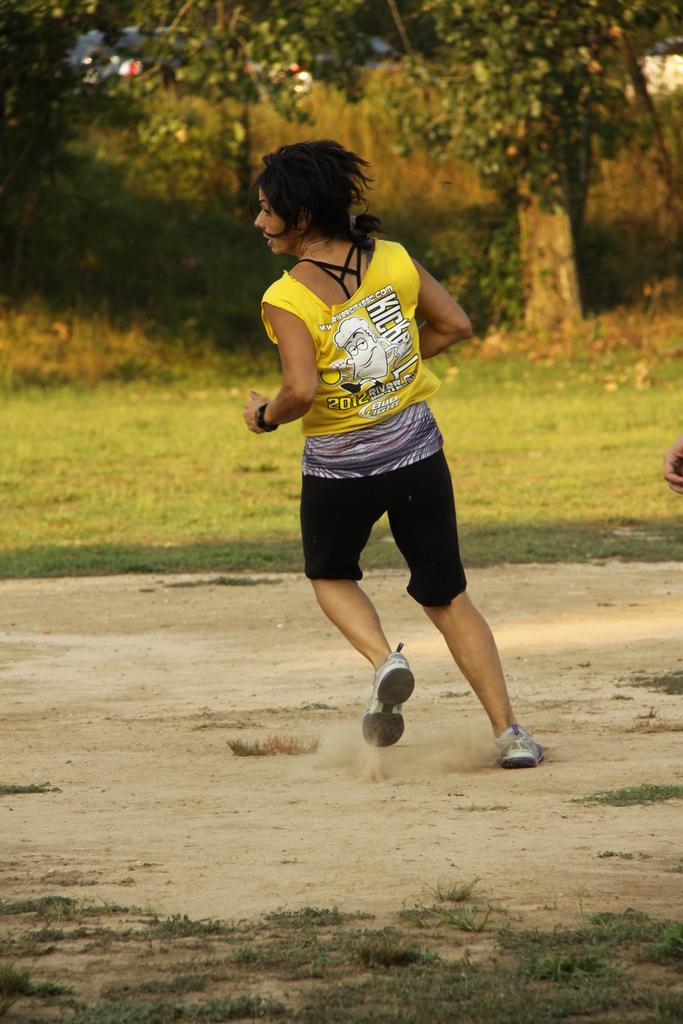Who is the main subject in the image? There is a lady in the image. What is the lady doing in the image? The lady is running. What type of surface is the lady running on? There is grass on the ground in front of the lady. What can be seen in the background of the image? There are trees in the background of the image. How many snakes are crawling on the lady's foot in the image? There are no snakes present in the image, and the lady's foot is not visible. What is the distance between the lady and the trees in the background? The distance between the lady and the trees in the background cannot be determined from the image alone. 